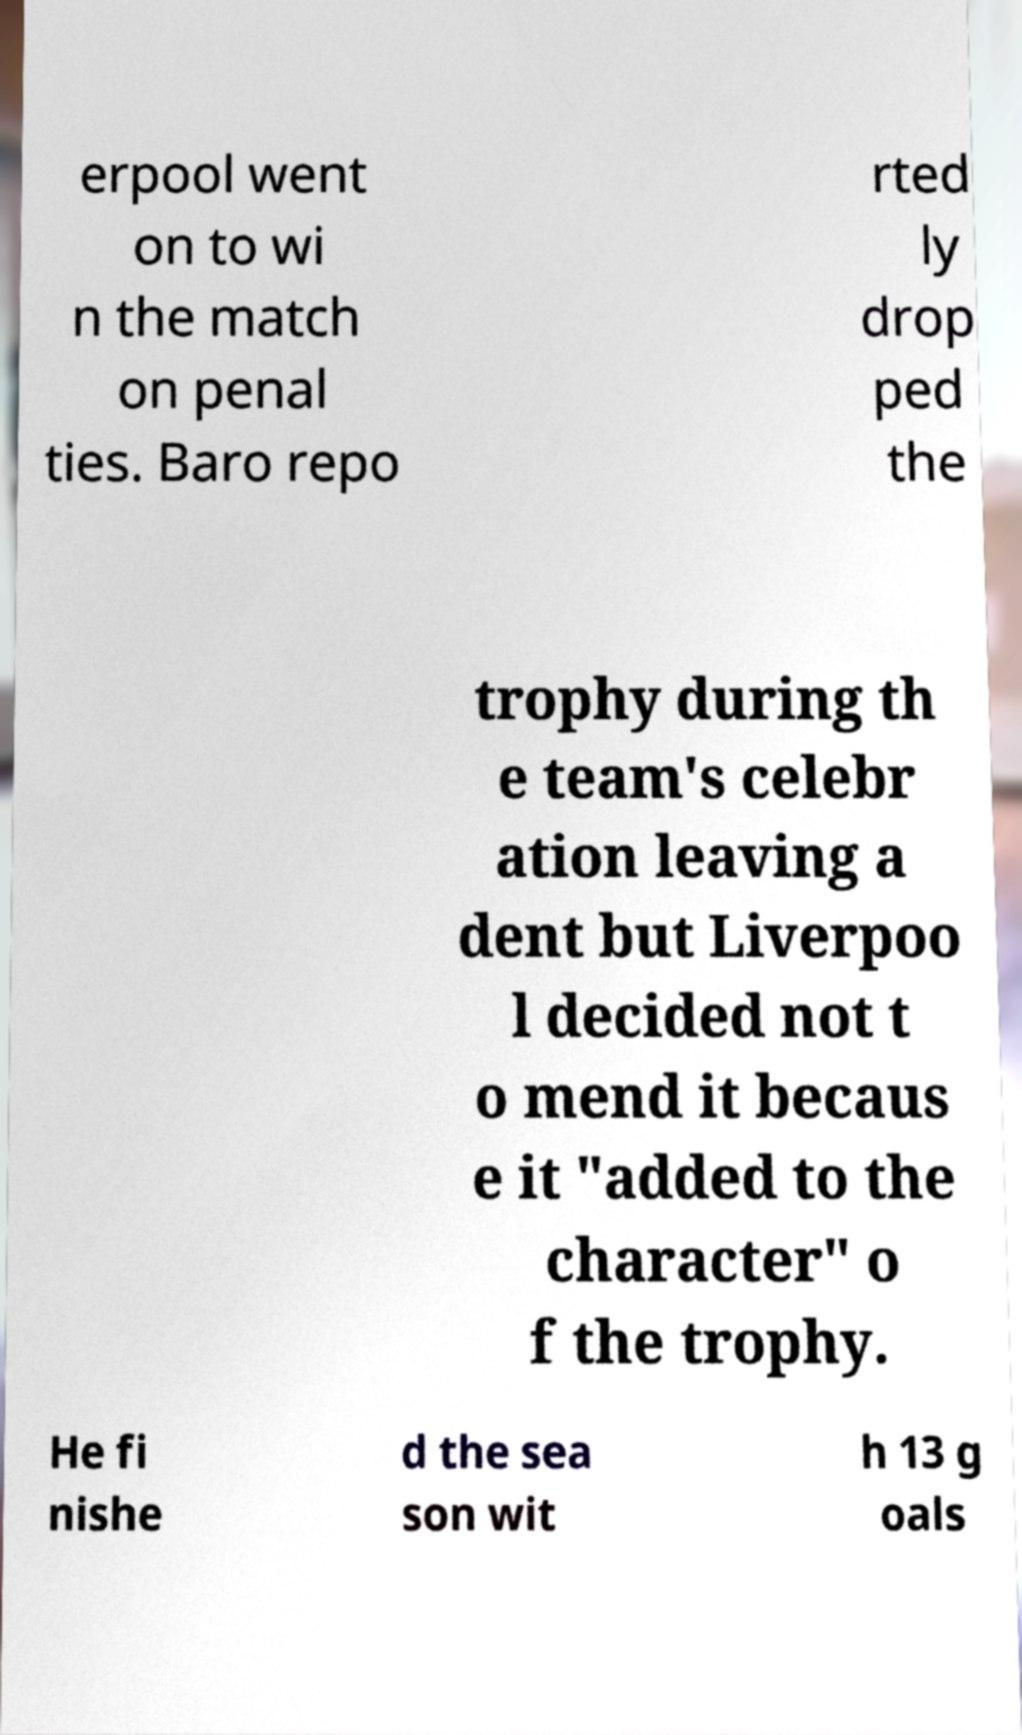Can you read and provide the text displayed in the image?This photo seems to have some interesting text. Can you extract and type it out for me? erpool went on to wi n the match on penal ties. Baro repo rted ly drop ped the trophy during th e team's celebr ation leaving a dent but Liverpoo l decided not t o mend it becaus e it "added to the character" o f the trophy. He fi nishe d the sea son wit h 13 g oals 